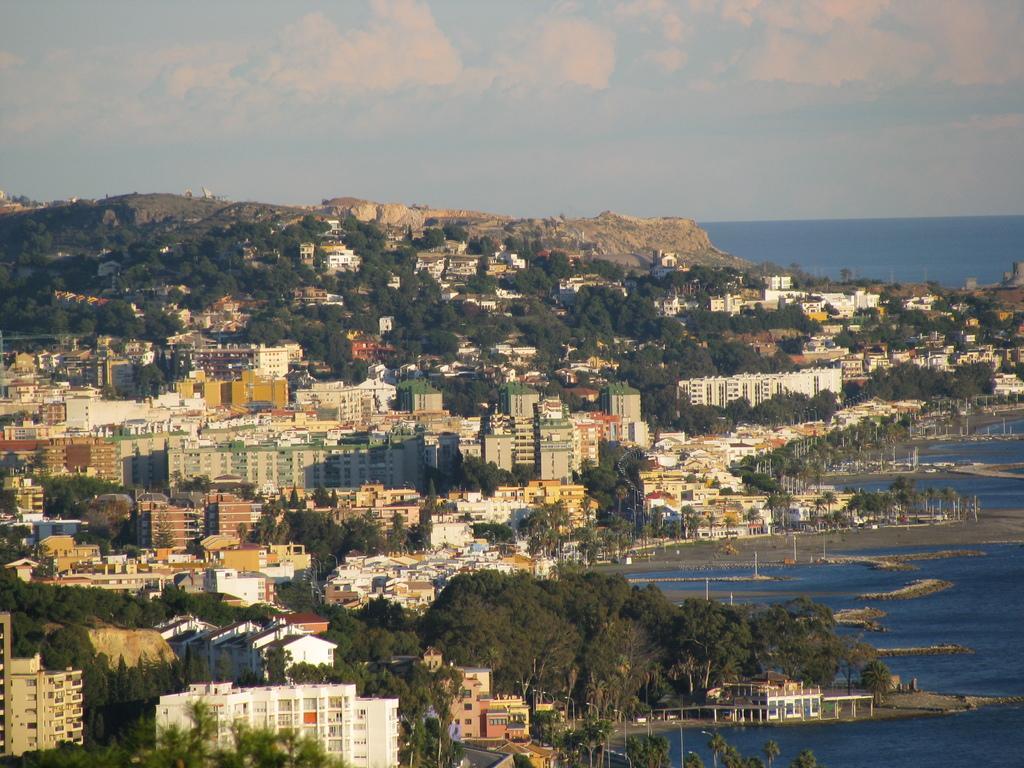In one or two sentences, can you explain what this image depicts? In this image I can see few buildings and windows. We can see trees and light-poles. Back I can see mountains and a water. The sky is in blue and white color. 